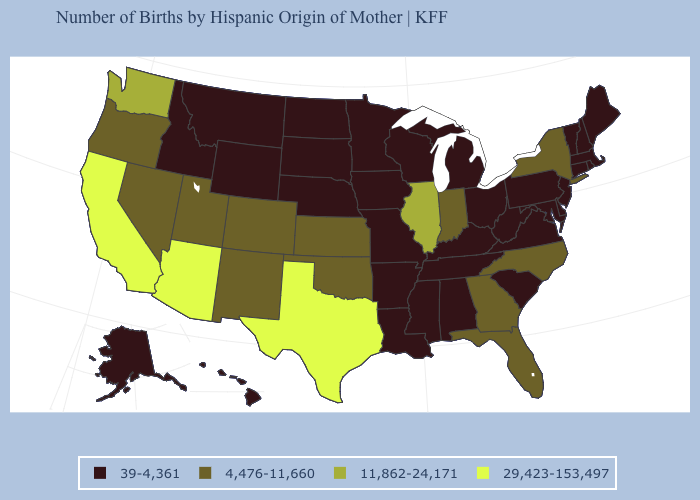What is the value of Rhode Island?
Be succinct. 39-4,361. What is the highest value in states that border New Jersey?
Give a very brief answer. 4,476-11,660. Among the states that border North Carolina , does Tennessee have the lowest value?
Short answer required. Yes. What is the value of Hawaii?
Write a very short answer. 39-4,361. Name the states that have a value in the range 4,476-11,660?
Write a very short answer. Colorado, Florida, Georgia, Indiana, Kansas, Nevada, New Mexico, New York, North Carolina, Oklahoma, Oregon, Utah. Does Rhode Island have the highest value in the Northeast?
Be succinct. No. Does New Jersey have a lower value than North Dakota?
Write a very short answer. No. Is the legend a continuous bar?
Short answer required. No. Which states have the lowest value in the USA?
Give a very brief answer. Alabama, Alaska, Arkansas, Connecticut, Delaware, Hawaii, Idaho, Iowa, Kentucky, Louisiana, Maine, Maryland, Massachusetts, Michigan, Minnesota, Mississippi, Missouri, Montana, Nebraska, New Hampshire, New Jersey, North Dakota, Ohio, Pennsylvania, Rhode Island, South Carolina, South Dakota, Tennessee, Vermont, Virginia, West Virginia, Wisconsin, Wyoming. Which states hav the highest value in the West?
Answer briefly. Arizona, California. Among the states that border Oklahoma , does New Mexico have the lowest value?
Answer briefly. No. Among the states that border North Carolina , which have the lowest value?
Answer briefly. South Carolina, Tennessee, Virginia. What is the value of Arizona?
Short answer required. 29,423-153,497. Which states have the lowest value in the USA?
Write a very short answer. Alabama, Alaska, Arkansas, Connecticut, Delaware, Hawaii, Idaho, Iowa, Kentucky, Louisiana, Maine, Maryland, Massachusetts, Michigan, Minnesota, Mississippi, Missouri, Montana, Nebraska, New Hampshire, New Jersey, North Dakota, Ohio, Pennsylvania, Rhode Island, South Carolina, South Dakota, Tennessee, Vermont, Virginia, West Virginia, Wisconsin, Wyoming. Name the states that have a value in the range 39-4,361?
Write a very short answer. Alabama, Alaska, Arkansas, Connecticut, Delaware, Hawaii, Idaho, Iowa, Kentucky, Louisiana, Maine, Maryland, Massachusetts, Michigan, Minnesota, Mississippi, Missouri, Montana, Nebraska, New Hampshire, New Jersey, North Dakota, Ohio, Pennsylvania, Rhode Island, South Carolina, South Dakota, Tennessee, Vermont, Virginia, West Virginia, Wisconsin, Wyoming. 